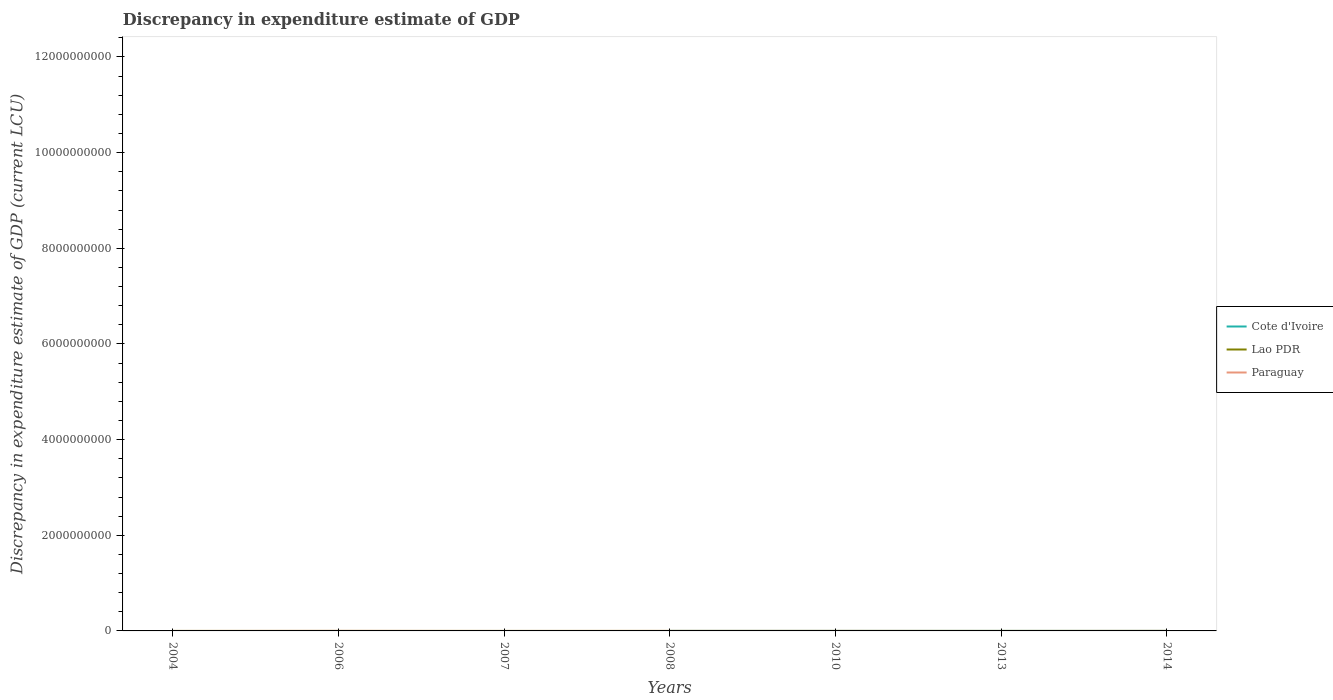How many different coloured lines are there?
Give a very brief answer. 3. Is the number of lines equal to the number of legend labels?
Provide a succinct answer. No. Across all years, what is the maximum discrepancy in expenditure estimate of GDP in Lao PDR?
Provide a short and direct response. 0. What is the total discrepancy in expenditure estimate of GDP in Lao PDR in the graph?
Your answer should be very brief. 99.91. What is the difference between the highest and the second highest discrepancy in expenditure estimate of GDP in Cote d'Ivoire?
Give a very brief answer. 0.02. How many lines are there?
Ensure brevity in your answer.  3. How many years are there in the graph?
Provide a succinct answer. 7. Does the graph contain grids?
Give a very brief answer. No. What is the title of the graph?
Provide a short and direct response. Discrepancy in expenditure estimate of GDP. Does "Curacao" appear as one of the legend labels in the graph?
Your response must be concise. No. What is the label or title of the X-axis?
Offer a terse response. Years. What is the label or title of the Y-axis?
Your answer should be very brief. Discrepancy in expenditure estimate of GDP (current LCU). What is the Discrepancy in expenditure estimate of GDP (current LCU) in Cote d'Ivoire in 2006?
Your response must be concise. 0. What is the Discrepancy in expenditure estimate of GDP (current LCU) in Lao PDR in 2006?
Provide a short and direct response. 99.99. What is the Discrepancy in expenditure estimate of GDP (current LCU) of Paraguay in 2006?
Ensure brevity in your answer.  1.00e+06. What is the Discrepancy in expenditure estimate of GDP (current LCU) in Cote d'Ivoire in 2007?
Ensure brevity in your answer.  0. What is the Discrepancy in expenditure estimate of GDP (current LCU) in Lao PDR in 2007?
Keep it short and to the point. 0.01. What is the Discrepancy in expenditure estimate of GDP (current LCU) of Paraguay in 2007?
Offer a terse response. 0. What is the Discrepancy in expenditure estimate of GDP (current LCU) in Paraguay in 2008?
Offer a terse response. 0. What is the Discrepancy in expenditure estimate of GDP (current LCU) in Cote d'Ivoire in 2010?
Provide a succinct answer. 0. What is the Discrepancy in expenditure estimate of GDP (current LCU) of Lao PDR in 2010?
Offer a very short reply. 0.01. What is the Discrepancy in expenditure estimate of GDP (current LCU) of Paraguay in 2010?
Make the answer very short. 0.02. What is the Discrepancy in expenditure estimate of GDP (current LCU) of Cote d'Ivoire in 2013?
Provide a succinct answer. 0.02. What is the Discrepancy in expenditure estimate of GDP (current LCU) in Lao PDR in 2013?
Give a very brief answer. 0.09. What is the Discrepancy in expenditure estimate of GDP (current LCU) in Paraguay in 2013?
Provide a short and direct response. 0. What is the Discrepancy in expenditure estimate of GDP (current LCU) in Lao PDR in 2014?
Provide a short and direct response. 0.14. What is the Discrepancy in expenditure estimate of GDP (current LCU) in Paraguay in 2014?
Give a very brief answer. 100.01. Across all years, what is the maximum Discrepancy in expenditure estimate of GDP (current LCU) of Cote d'Ivoire?
Make the answer very short. 0.02. Across all years, what is the maximum Discrepancy in expenditure estimate of GDP (current LCU) in Lao PDR?
Your response must be concise. 100. Across all years, what is the maximum Discrepancy in expenditure estimate of GDP (current LCU) in Paraguay?
Keep it short and to the point. 1.00e+06. Across all years, what is the minimum Discrepancy in expenditure estimate of GDP (current LCU) in Cote d'Ivoire?
Keep it short and to the point. 0. Across all years, what is the minimum Discrepancy in expenditure estimate of GDP (current LCU) of Paraguay?
Offer a terse response. 0. What is the total Discrepancy in expenditure estimate of GDP (current LCU) in Cote d'Ivoire in the graph?
Offer a very short reply. 0.02. What is the total Discrepancy in expenditure estimate of GDP (current LCU) of Lao PDR in the graph?
Make the answer very short. 200.24. What is the total Discrepancy in expenditure estimate of GDP (current LCU) of Paraguay in the graph?
Your answer should be very brief. 1.00e+06. What is the difference between the Discrepancy in expenditure estimate of GDP (current LCU) in Lao PDR in 2006 and that in 2007?
Give a very brief answer. 99.98. What is the difference between the Discrepancy in expenditure estimate of GDP (current LCU) of Lao PDR in 2006 and that in 2008?
Your answer should be compact. -0.01. What is the difference between the Discrepancy in expenditure estimate of GDP (current LCU) in Lao PDR in 2006 and that in 2010?
Keep it short and to the point. 99.98. What is the difference between the Discrepancy in expenditure estimate of GDP (current LCU) of Paraguay in 2006 and that in 2010?
Ensure brevity in your answer.  1.00e+06. What is the difference between the Discrepancy in expenditure estimate of GDP (current LCU) of Lao PDR in 2006 and that in 2013?
Ensure brevity in your answer.  99.9. What is the difference between the Discrepancy in expenditure estimate of GDP (current LCU) of Lao PDR in 2006 and that in 2014?
Your response must be concise. 99.85. What is the difference between the Discrepancy in expenditure estimate of GDP (current LCU) in Paraguay in 2006 and that in 2014?
Ensure brevity in your answer.  1.00e+06. What is the difference between the Discrepancy in expenditure estimate of GDP (current LCU) in Lao PDR in 2007 and that in 2008?
Keep it short and to the point. -99.99. What is the difference between the Discrepancy in expenditure estimate of GDP (current LCU) in Lao PDR in 2007 and that in 2010?
Provide a short and direct response. -0. What is the difference between the Discrepancy in expenditure estimate of GDP (current LCU) of Lao PDR in 2007 and that in 2013?
Ensure brevity in your answer.  -0.08. What is the difference between the Discrepancy in expenditure estimate of GDP (current LCU) in Lao PDR in 2007 and that in 2014?
Provide a succinct answer. -0.13. What is the difference between the Discrepancy in expenditure estimate of GDP (current LCU) of Lao PDR in 2008 and that in 2010?
Provide a short and direct response. 99.99. What is the difference between the Discrepancy in expenditure estimate of GDP (current LCU) in Cote d'Ivoire in 2008 and that in 2013?
Make the answer very short. -0.02. What is the difference between the Discrepancy in expenditure estimate of GDP (current LCU) of Lao PDR in 2008 and that in 2013?
Your answer should be compact. 99.91. What is the difference between the Discrepancy in expenditure estimate of GDP (current LCU) of Lao PDR in 2008 and that in 2014?
Offer a terse response. 99.86. What is the difference between the Discrepancy in expenditure estimate of GDP (current LCU) of Lao PDR in 2010 and that in 2013?
Offer a terse response. -0.08. What is the difference between the Discrepancy in expenditure estimate of GDP (current LCU) in Lao PDR in 2010 and that in 2014?
Provide a short and direct response. -0.13. What is the difference between the Discrepancy in expenditure estimate of GDP (current LCU) in Paraguay in 2010 and that in 2014?
Make the answer very short. -99.98. What is the difference between the Discrepancy in expenditure estimate of GDP (current LCU) in Lao PDR in 2013 and that in 2014?
Provide a succinct answer. -0.05. What is the difference between the Discrepancy in expenditure estimate of GDP (current LCU) in Lao PDR in 2006 and the Discrepancy in expenditure estimate of GDP (current LCU) in Paraguay in 2010?
Give a very brief answer. 99.97. What is the difference between the Discrepancy in expenditure estimate of GDP (current LCU) in Lao PDR in 2006 and the Discrepancy in expenditure estimate of GDP (current LCU) in Paraguay in 2014?
Keep it short and to the point. -0.01. What is the difference between the Discrepancy in expenditure estimate of GDP (current LCU) of Lao PDR in 2007 and the Discrepancy in expenditure estimate of GDP (current LCU) of Paraguay in 2010?
Give a very brief answer. -0.02. What is the difference between the Discrepancy in expenditure estimate of GDP (current LCU) in Lao PDR in 2007 and the Discrepancy in expenditure estimate of GDP (current LCU) in Paraguay in 2014?
Offer a very short reply. -100. What is the difference between the Discrepancy in expenditure estimate of GDP (current LCU) of Cote d'Ivoire in 2008 and the Discrepancy in expenditure estimate of GDP (current LCU) of Lao PDR in 2010?
Give a very brief answer. -0.01. What is the difference between the Discrepancy in expenditure estimate of GDP (current LCU) in Cote d'Ivoire in 2008 and the Discrepancy in expenditure estimate of GDP (current LCU) in Paraguay in 2010?
Your answer should be very brief. -0.02. What is the difference between the Discrepancy in expenditure estimate of GDP (current LCU) in Lao PDR in 2008 and the Discrepancy in expenditure estimate of GDP (current LCU) in Paraguay in 2010?
Your answer should be very brief. 99.98. What is the difference between the Discrepancy in expenditure estimate of GDP (current LCU) in Cote d'Ivoire in 2008 and the Discrepancy in expenditure estimate of GDP (current LCU) in Lao PDR in 2013?
Your response must be concise. -0.09. What is the difference between the Discrepancy in expenditure estimate of GDP (current LCU) of Cote d'Ivoire in 2008 and the Discrepancy in expenditure estimate of GDP (current LCU) of Lao PDR in 2014?
Offer a very short reply. -0.14. What is the difference between the Discrepancy in expenditure estimate of GDP (current LCU) in Cote d'Ivoire in 2008 and the Discrepancy in expenditure estimate of GDP (current LCU) in Paraguay in 2014?
Offer a very short reply. -100. What is the difference between the Discrepancy in expenditure estimate of GDP (current LCU) in Lao PDR in 2008 and the Discrepancy in expenditure estimate of GDP (current LCU) in Paraguay in 2014?
Give a very brief answer. -0.01. What is the difference between the Discrepancy in expenditure estimate of GDP (current LCU) in Lao PDR in 2010 and the Discrepancy in expenditure estimate of GDP (current LCU) in Paraguay in 2014?
Provide a short and direct response. -99.99. What is the difference between the Discrepancy in expenditure estimate of GDP (current LCU) of Cote d'Ivoire in 2013 and the Discrepancy in expenditure estimate of GDP (current LCU) of Lao PDR in 2014?
Provide a succinct answer. -0.12. What is the difference between the Discrepancy in expenditure estimate of GDP (current LCU) in Cote d'Ivoire in 2013 and the Discrepancy in expenditure estimate of GDP (current LCU) in Paraguay in 2014?
Offer a terse response. -99.98. What is the difference between the Discrepancy in expenditure estimate of GDP (current LCU) in Lao PDR in 2013 and the Discrepancy in expenditure estimate of GDP (current LCU) in Paraguay in 2014?
Keep it short and to the point. -99.92. What is the average Discrepancy in expenditure estimate of GDP (current LCU) in Cote d'Ivoire per year?
Provide a short and direct response. 0. What is the average Discrepancy in expenditure estimate of GDP (current LCU) in Lao PDR per year?
Ensure brevity in your answer.  28.61. What is the average Discrepancy in expenditure estimate of GDP (current LCU) of Paraguay per year?
Your answer should be very brief. 1.43e+05. In the year 2006, what is the difference between the Discrepancy in expenditure estimate of GDP (current LCU) of Lao PDR and Discrepancy in expenditure estimate of GDP (current LCU) of Paraguay?
Offer a very short reply. -1.00e+06. In the year 2008, what is the difference between the Discrepancy in expenditure estimate of GDP (current LCU) in Cote d'Ivoire and Discrepancy in expenditure estimate of GDP (current LCU) in Lao PDR?
Provide a short and direct response. -100. In the year 2010, what is the difference between the Discrepancy in expenditure estimate of GDP (current LCU) of Lao PDR and Discrepancy in expenditure estimate of GDP (current LCU) of Paraguay?
Provide a succinct answer. -0.01. In the year 2013, what is the difference between the Discrepancy in expenditure estimate of GDP (current LCU) in Cote d'Ivoire and Discrepancy in expenditure estimate of GDP (current LCU) in Lao PDR?
Provide a short and direct response. -0.07. In the year 2014, what is the difference between the Discrepancy in expenditure estimate of GDP (current LCU) of Lao PDR and Discrepancy in expenditure estimate of GDP (current LCU) of Paraguay?
Your response must be concise. -99.87. What is the ratio of the Discrepancy in expenditure estimate of GDP (current LCU) of Lao PDR in 2006 to that in 2007?
Give a very brief answer. 1.25e+04. What is the ratio of the Discrepancy in expenditure estimate of GDP (current LCU) of Lao PDR in 2006 to that in 2010?
Provide a succinct answer. 8332.67. What is the ratio of the Discrepancy in expenditure estimate of GDP (current LCU) of Paraguay in 2006 to that in 2010?
Your answer should be very brief. 4.17e+07. What is the ratio of the Discrepancy in expenditure estimate of GDP (current LCU) in Lao PDR in 2006 to that in 2013?
Offer a very short reply. 1123.51. What is the ratio of the Discrepancy in expenditure estimate of GDP (current LCU) of Lao PDR in 2006 to that in 2014?
Offer a very short reply. 719.37. What is the ratio of the Discrepancy in expenditure estimate of GDP (current LCU) in Paraguay in 2006 to that in 2014?
Your answer should be compact. 9999.4. What is the ratio of the Discrepancy in expenditure estimate of GDP (current LCU) in Lao PDR in 2007 to that in 2010?
Make the answer very short. 0.67. What is the ratio of the Discrepancy in expenditure estimate of GDP (current LCU) in Lao PDR in 2007 to that in 2013?
Make the answer very short. 0.09. What is the ratio of the Discrepancy in expenditure estimate of GDP (current LCU) of Lao PDR in 2007 to that in 2014?
Give a very brief answer. 0.06. What is the ratio of the Discrepancy in expenditure estimate of GDP (current LCU) in Lao PDR in 2008 to that in 2010?
Make the answer very short. 8333.33. What is the ratio of the Discrepancy in expenditure estimate of GDP (current LCU) in Cote d'Ivoire in 2008 to that in 2013?
Provide a succinct answer. 0.05. What is the ratio of the Discrepancy in expenditure estimate of GDP (current LCU) in Lao PDR in 2008 to that in 2013?
Your answer should be compact. 1123.6. What is the ratio of the Discrepancy in expenditure estimate of GDP (current LCU) in Lao PDR in 2008 to that in 2014?
Provide a succinct answer. 719.42. What is the ratio of the Discrepancy in expenditure estimate of GDP (current LCU) of Lao PDR in 2010 to that in 2013?
Your answer should be compact. 0.13. What is the ratio of the Discrepancy in expenditure estimate of GDP (current LCU) of Lao PDR in 2010 to that in 2014?
Provide a short and direct response. 0.09. What is the ratio of the Discrepancy in expenditure estimate of GDP (current LCU) of Lao PDR in 2013 to that in 2014?
Give a very brief answer. 0.64. What is the difference between the highest and the second highest Discrepancy in expenditure estimate of GDP (current LCU) in Lao PDR?
Your response must be concise. 0.01. What is the difference between the highest and the second highest Discrepancy in expenditure estimate of GDP (current LCU) of Paraguay?
Your response must be concise. 1.00e+06. What is the difference between the highest and the lowest Discrepancy in expenditure estimate of GDP (current LCU) in Cote d'Ivoire?
Offer a very short reply. 0.02. What is the difference between the highest and the lowest Discrepancy in expenditure estimate of GDP (current LCU) in Lao PDR?
Make the answer very short. 100. What is the difference between the highest and the lowest Discrepancy in expenditure estimate of GDP (current LCU) of Paraguay?
Your answer should be very brief. 1.00e+06. 